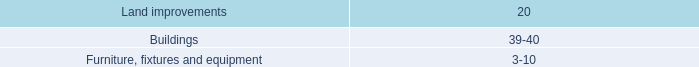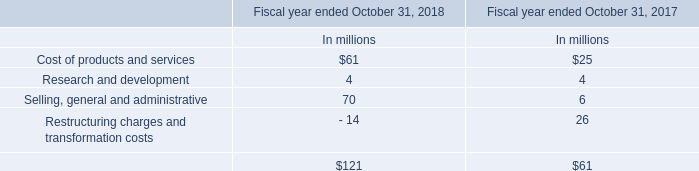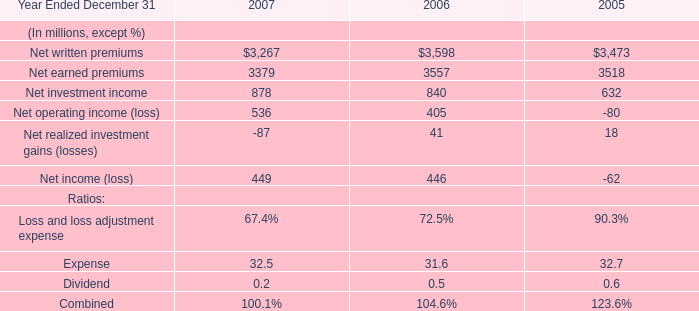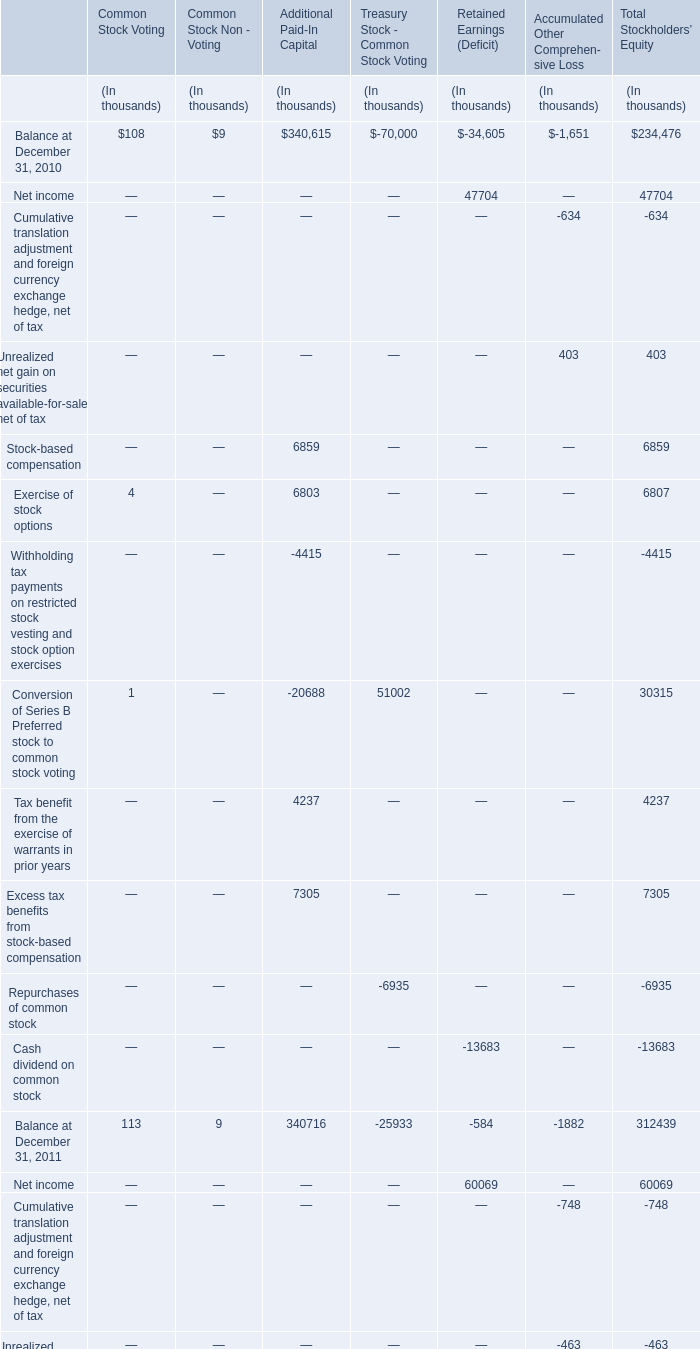What is the percentage of all Common Stock Votingthat are positive to the total amount, in 2010? 
Computations: (((108 + 4) + 1) / 113)
Answer: 1.0. 